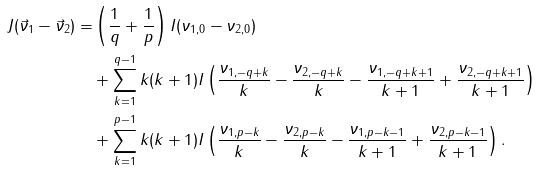Convert formula to latex. <formula><loc_0><loc_0><loc_500><loc_500>J ( \vec { \nu } _ { 1 } - \vec { \nu } _ { 2 } ) = & \left ( \frac { 1 } { q } + \frac { 1 } { p } \right ) I ( \nu _ { 1 , 0 } - \nu _ { 2 , 0 } ) \\ & + \sum _ { k = 1 } ^ { q - 1 } k ( k + 1 ) I \left ( \frac { \nu _ { 1 , - q + k } } { k } - \frac { \nu _ { 2 , - q + k } } { k } - \frac { \nu _ { 1 , - q + k + 1 } } { k + 1 } + \frac { \nu _ { 2 , - q + k + 1 } } { k + 1 } \right ) \\ & + \sum _ { k = 1 } ^ { p - 1 } k ( k + 1 ) I \left ( \frac { \nu _ { 1 , p - k } } { k } - \frac { \nu _ { 2 , p - k } } { k } - \frac { \nu _ { 1 , p - k - 1 } } { k + 1 } + \frac { \nu _ { 2 , p - k - 1 } } { k + 1 } \right ) .</formula> 